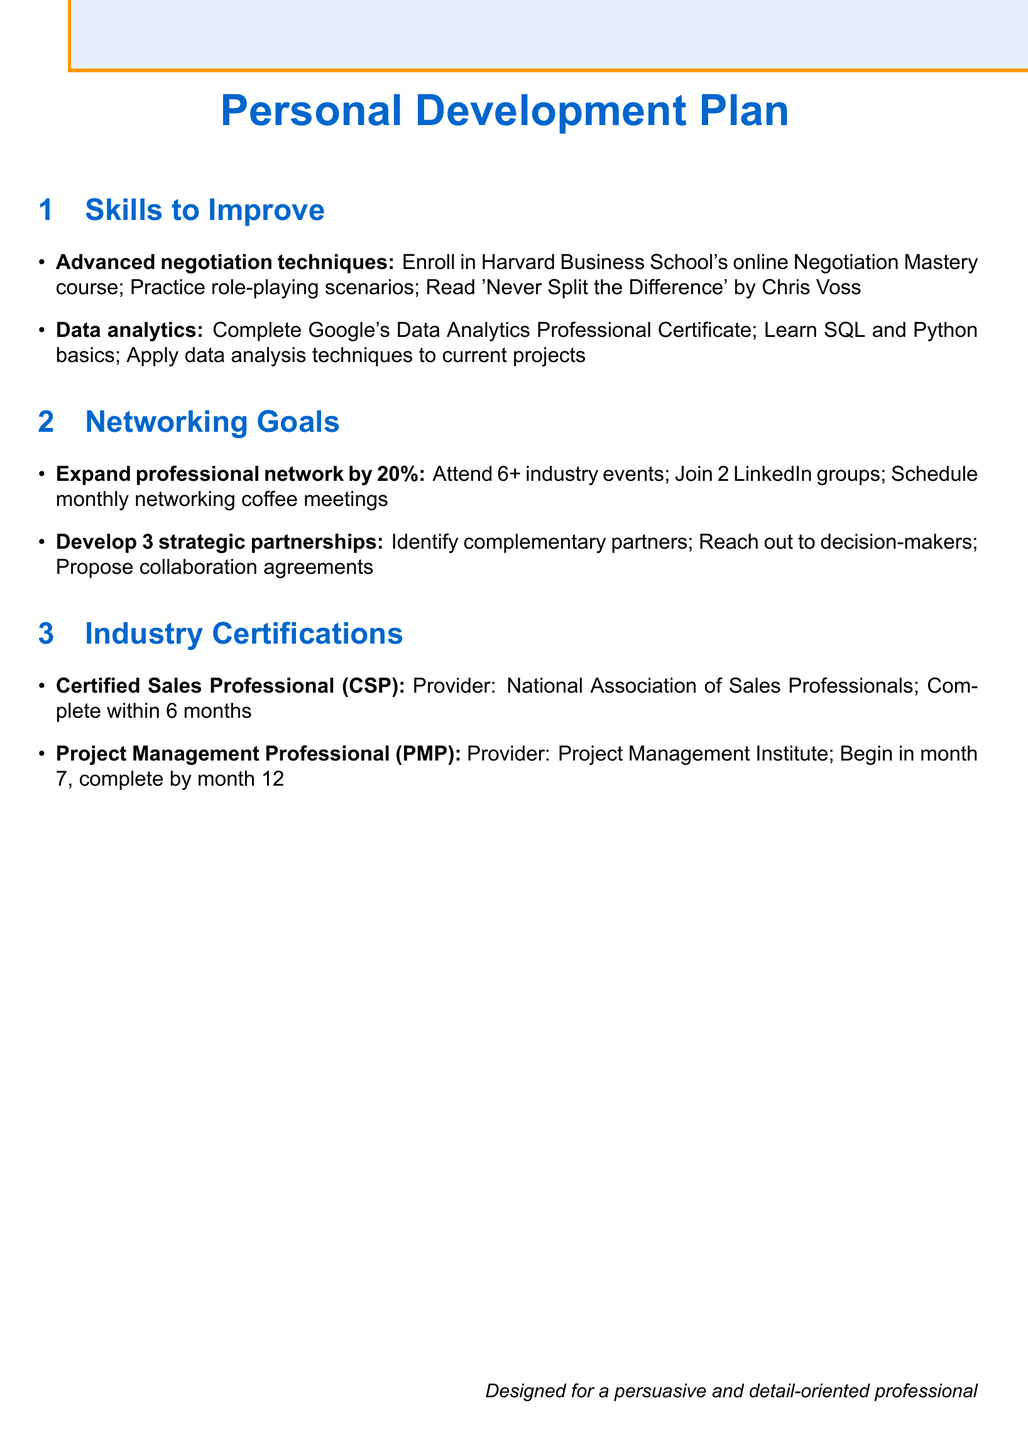What are the two skills to improve? The skills listed for improvement in the document are "Advanced negotiation techniques" and "Data analytics."
Answer: Advanced negotiation techniques, Data analytics What certification should be completed within 6 months? The document specifies the "Certified Sales Professional (CSP)" certification, which has a 6-month completion timeline.
Answer: Certified Sales Professional (CSP) How many industry events should be attended according to the networking goals? The networking goal states to "Attend at least 6 industry conferences or events."
Answer: 6 What is a recommended action item for learning data analytics? One of the action items is to "Complete Google's Data Analytics Professional Certificate," which is derived from the skills outlined.
Answer: Complete Google's Data Analytics Professional Certificate What is the goal for expanding the professional network? The document outlines the goal to "Expand professional network by 20%."
Answer: 20% Which provider offers the Project Management Professional certification? The document indicates that the "Project Management Professional (PMP)" certification is offered by the "Project Management Institute."
Answer: Project Management Institute What is one of the action items for developing strategic partnerships? One of the action items listed is to "Identify potential partners who complement our services."
Answer: Identify potential partners What book is recommended for improving negotiation techniques? The document suggests reading "Never Split the Difference" by Chris Voss as part of the action items for improving negotiation techniques.
Answer: Never Split the Difference How many strategic partnerships should be developed in the next 12 months? The networking goal states to "Develop 3 strategic partnerships," indicating a clear target.
Answer: 3 